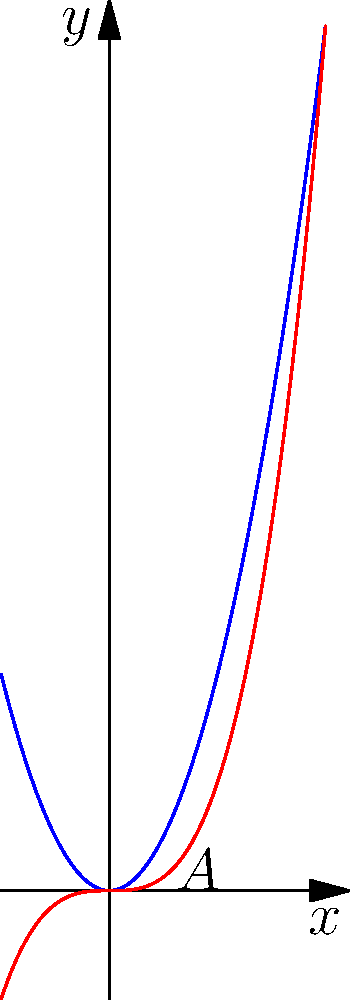Hey, remember when we were daydreaming about our secret treehouse? Let's imagine its unique curved roof is shaped by two intersecting functions: $y=2x^2$ and $y=x^3$. Can you calculate the area enclosed between these curves? It might come in handy for planning our dream hideout! Let's approach this step-by-step:

1) First, we need to find the points of intersection. Set the equations equal:
   $2x^2 = x^3$
   $x^3 - 2x^2 = 0$
   $x^2(x - 2) = 0$
   So, $x = 0$ or $x = 2$

2) The area between the curves is given by:
   $A = \int_{0}^{2} (2x^2 - x^3) dx$

3) Let's integrate:
   $A = \int_{0}^{2} (2x^2 - x^3) dx$
   $= [2\frac{x^3}{3} - \frac{x^4}{4}]_{0}^{2}$

4) Now, let's evaluate the integral:
   $A = (2\frac{2^3}{3} - \frac{2^4}{4}) - (2\frac{0^3}{3} - \frac{0^4}{4})$
   $= (2\frac{8}{3} - 4) - 0$
   $= \frac{16}{3} - 4$
   $= \frac{16}{3} - \frac{12}{3}$
   $= \frac{4}{3}$

So, the area between the curves is $\frac{4}{3}$ square units.
Answer: $\frac{4}{3}$ square units 